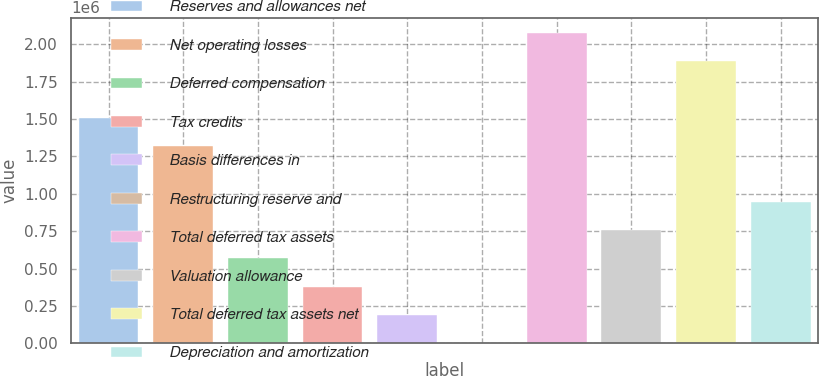<chart> <loc_0><loc_0><loc_500><loc_500><bar_chart><fcel>Reserves and allowances net<fcel>Net operating losses<fcel>Deferred compensation<fcel>Tax credits<fcel>Basis differences in<fcel>Restructuring reserve and<fcel>Total deferred tax assets<fcel>Valuation allowance<fcel>Total deferred tax assets net<fcel>Depreciation and amortization<nl><fcel>1.50972e+06<fcel>1.32127e+06<fcel>567496<fcel>379051<fcel>190607<fcel>2162<fcel>2.07505e+06<fcel>755941<fcel>1.88661e+06<fcel>944386<nl></chart> 